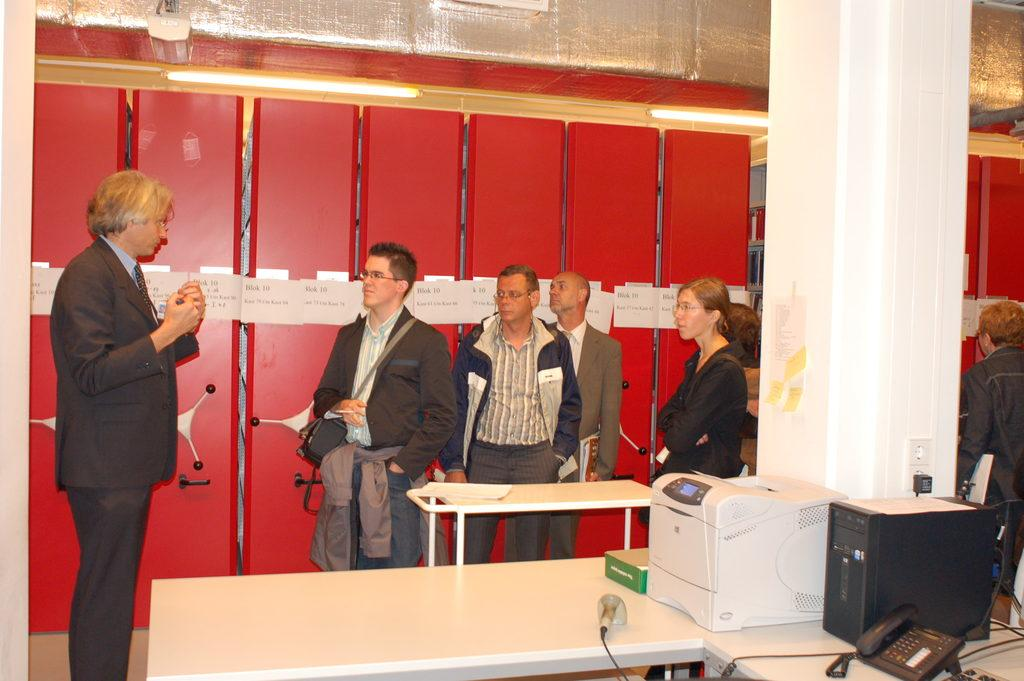What is happening in the image? There are people standing in the image. What objects are near the people? There are tables near the people. What is on the tables? There are equipment on the tables. What can be seen in the background of the image? There are lights on the ceiling in the background of the image. What shape is the mind of the person standing on the left in the image? There is no way to determine the shape of the mind of the person standing on the left in the image, as minds are not visible and have no shape. 